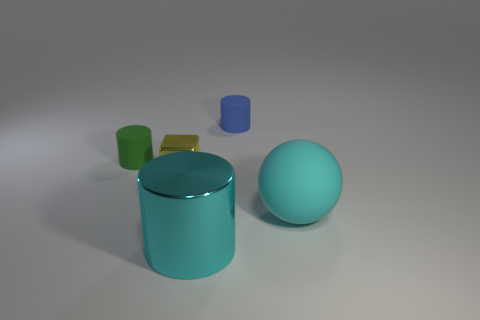Add 1 tiny blocks. How many objects exist? 6 Subtract all cylinders. How many objects are left? 2 Subtract 0 red cylinders. How many objects are left? 5 Subtract all large cyan metallic cylinders. Subtract all cyan shiny cylinders. How many objects are left? 3 Add 4 green objects. How many green objects are left? 5 Add 4 metallic things. How many metallic things exist? 6 